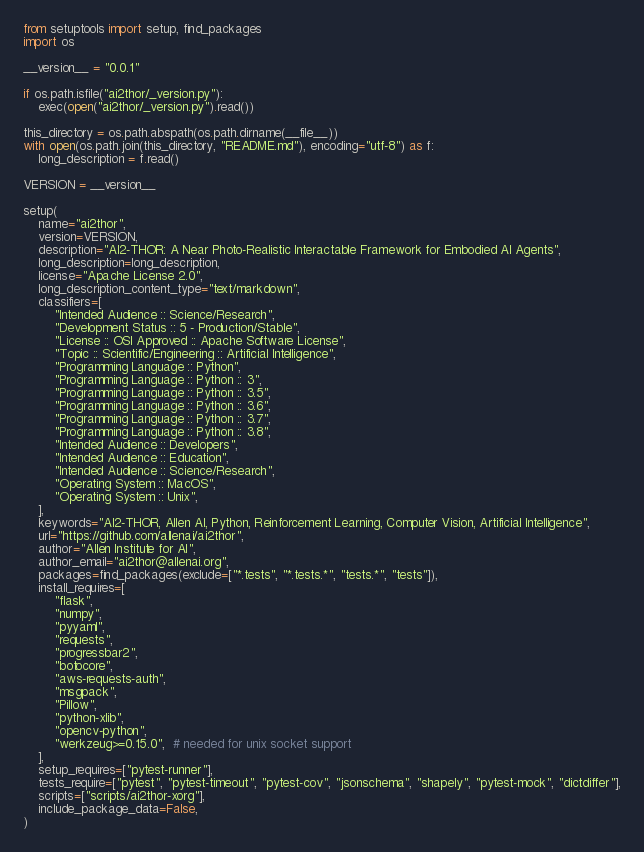<code> <loc_0><loc_0><loc_500><loc_500><_Python_>from setuptools import setup, find_packages
import os

__version__ = "0.0.1"

if os.path.isfile("ai2thor/_version.py"):
    exec(open("ai2thor/_version.py").read())

this_directory = os.path.abspath(os.path.dirname(__file__))
with open(os.path.join(this_directory, "README.md"), encoding="utf-8") as f:
    long_description = f.read()

VERSION = __version__

setup(
    name="ai2thor",
    version=VERSION,
    description="AI2-THOR: A Near Photo-Realistic Interactable Framework for Embodied AI Agents",
    long_description=long_description,
    license="Apache License 2.0",
    long_description_content_type="text/markdown",
    classifiers=[
        "Intended Audience :: Science/Research",
        "Development Status :: 5 - Production/Stable",
        "License :: OSI Approved :: Apache Software License",
        "Topic :: Scientific/Engineering :: Artificial Intelligence",
        "Programming Language :: Python",
        "Programming Language :: Python :: 3",
        "Programming Language :: Python :: 3.5",
        "Programming Language :: Python :: 3.6",
        "Programming Language :: Python :: 3.7",
        "Programming Language :: Python :: 3.8",
        "Intended Audience :: Developers",
        "Intended Audience :: Education",
        "Intended Audience :: Science/Research",
        "Operating System :: MacOS",
        "Operating System :: Unix",
    ],
    keywords="AI2-THOR, Allen AI, Python, Reinforcement Learning, Computer Vision, Artificial Intelligence",
    url="https://github.com/allenai/ai2thor",
    author="Allen Institute for AI",
    author_email="ai2thor@allenai.org",
    packages=find_packages(exclude=["*.tests", "*.tests.*", "tests.*", "tests"]),
    install_requires=[
        "flask",
        "numpy",
        "pyyaml",
        "requests",
        "progressbar2",
        "botocore",
        "aws-requests-auth",
        "msgpack",
        "Pillow",
        "python-xlib",
        "opencv-python",
        "werkzeug>=0.15.0",  # needed for unix socket support
    ],
    setup_requires=["pytest-runner"],
    tests_require=["pytest", "pytest-timeout", "pytest-cov", "jsonschema", "shapely", "pytest-mock", "dictdiffer"],
    scripts=["scripts/ai2thor-xorg"],
    include_package_data=False,
)
</code> 